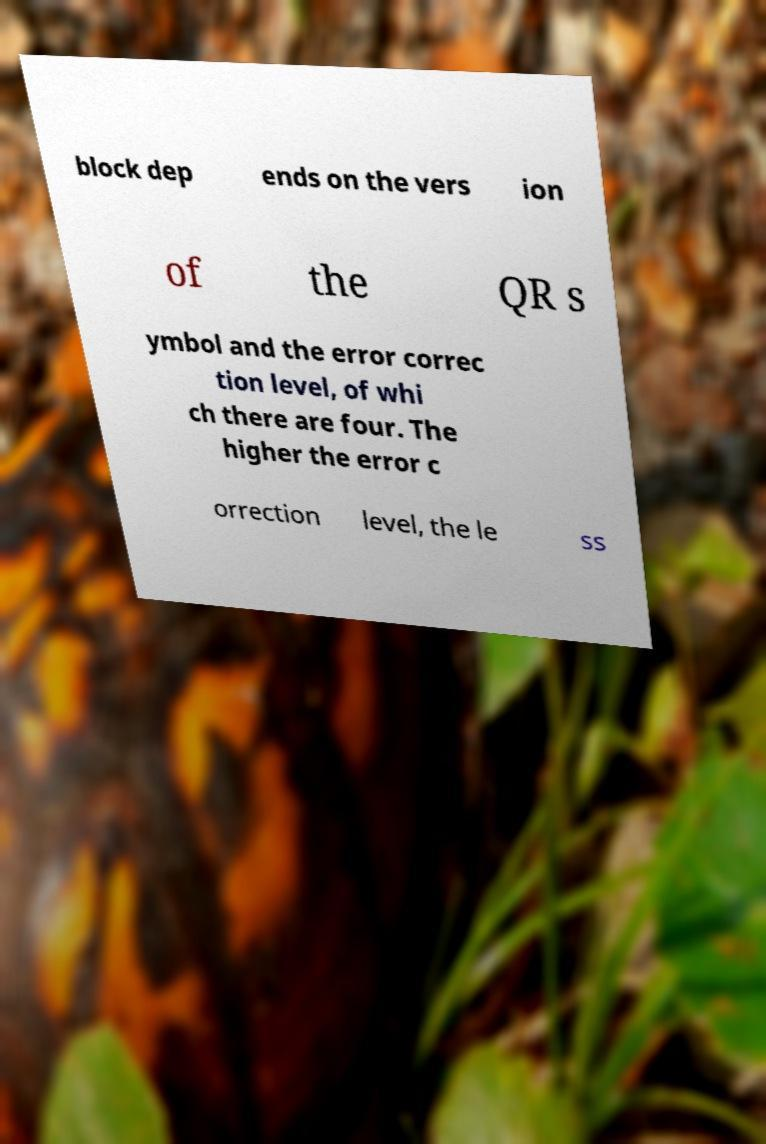Can you accurately transcribe the text from the provided image for me? block dep ends on the vers ion of the QR s ymbol and the error correc tion level, of whi ch there are four. The higher the error c orrection level, the le ss 